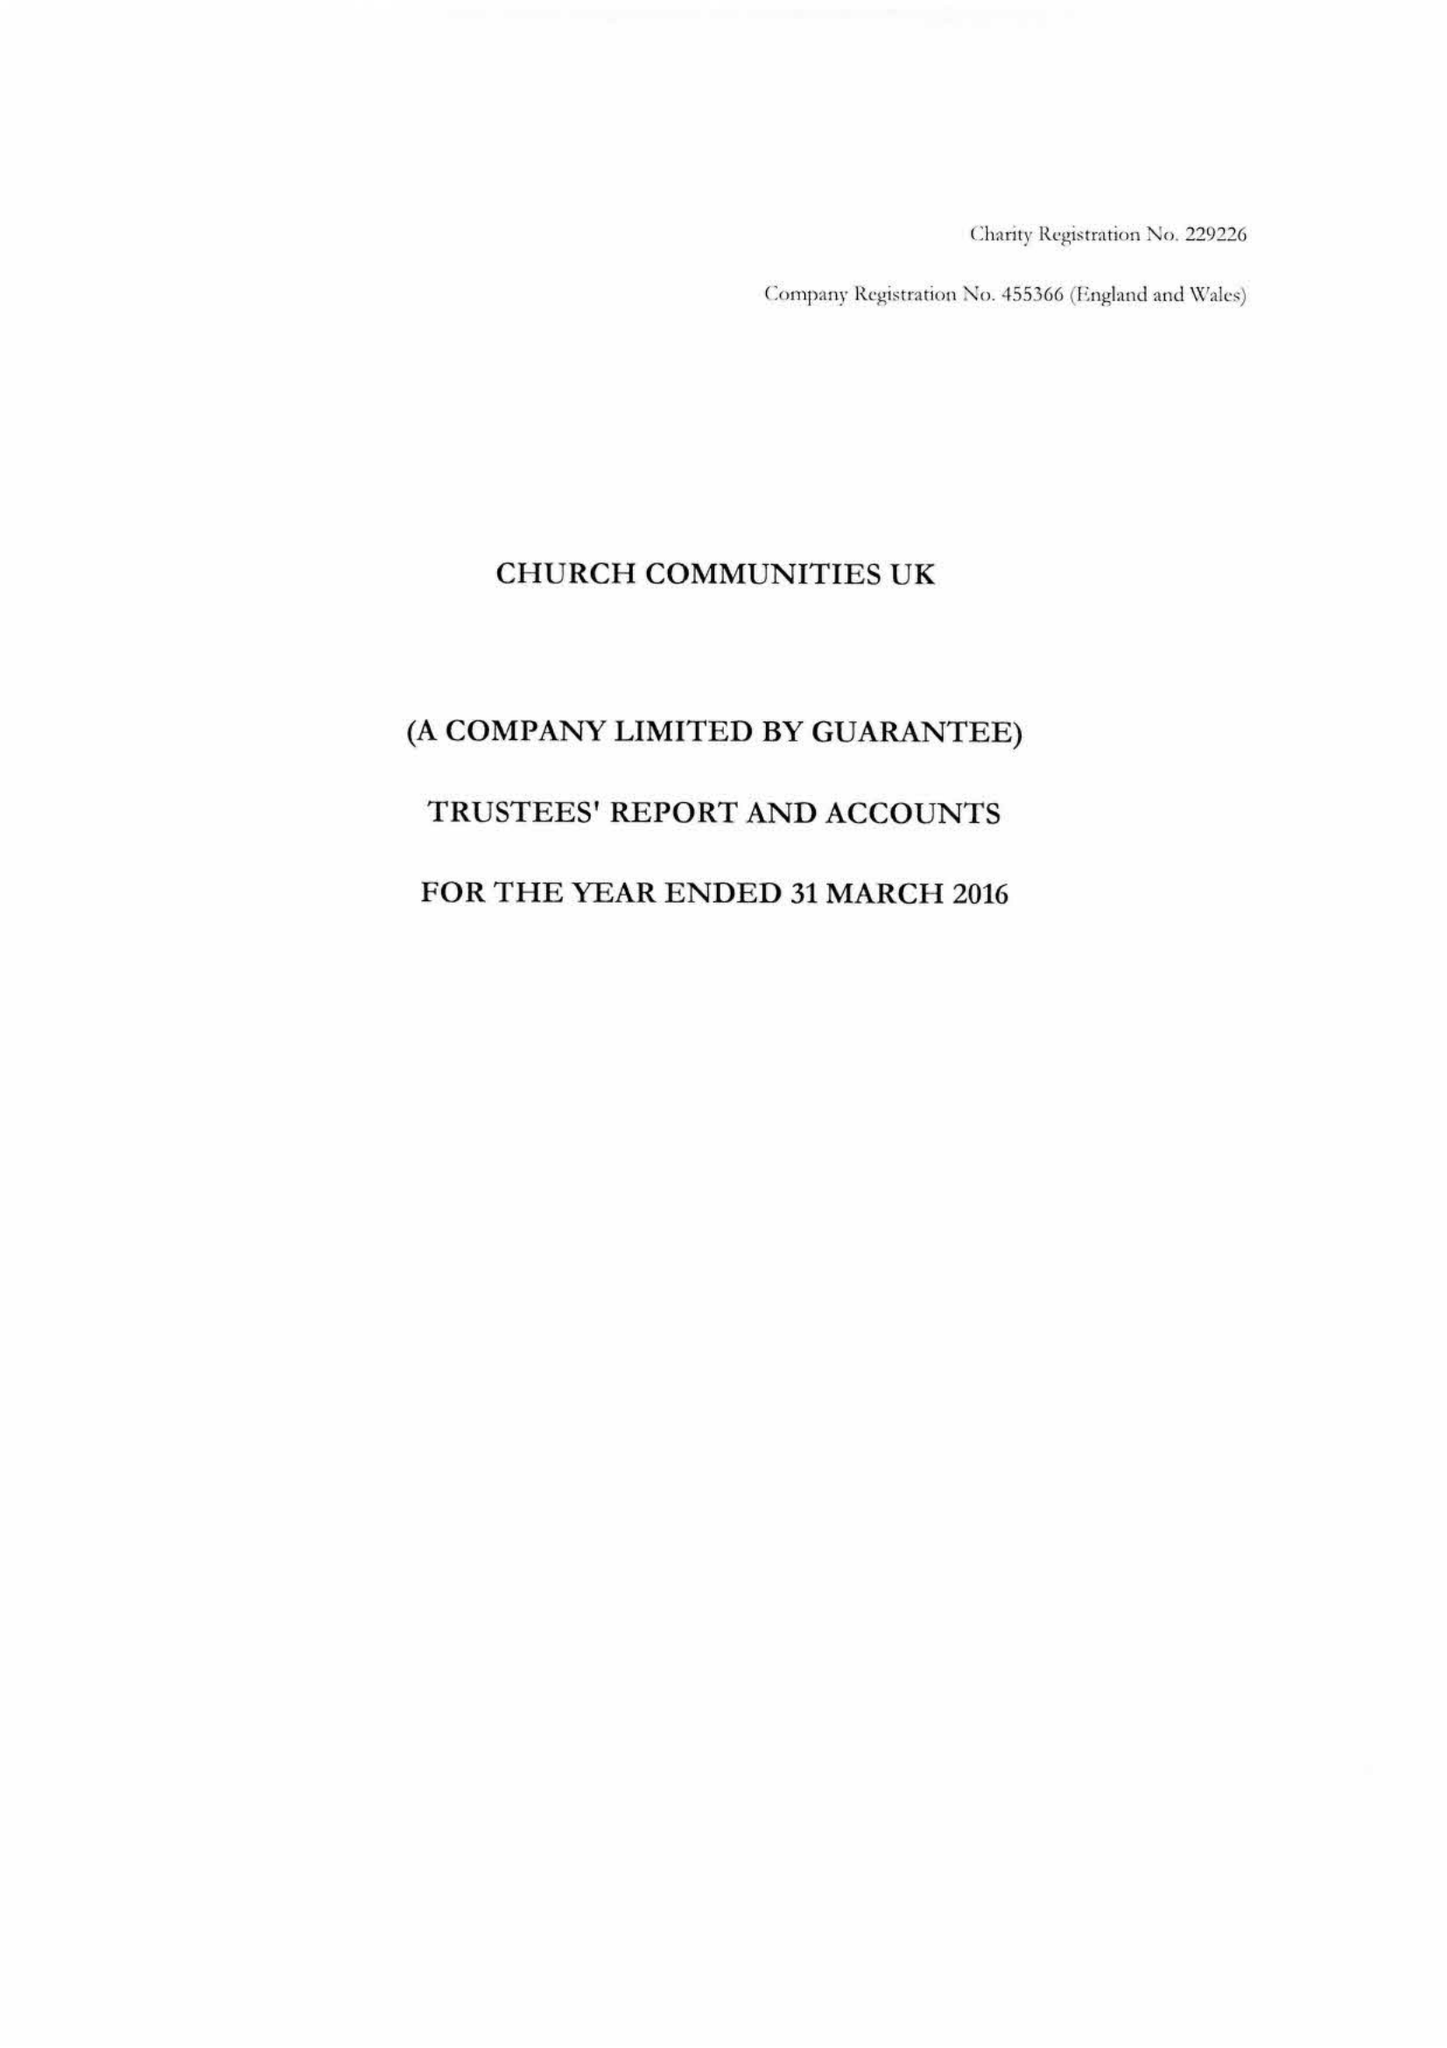What is the value for the spending_annually_in_british_pounds?
Answer the question using a single word or phrase. 20590093.00 